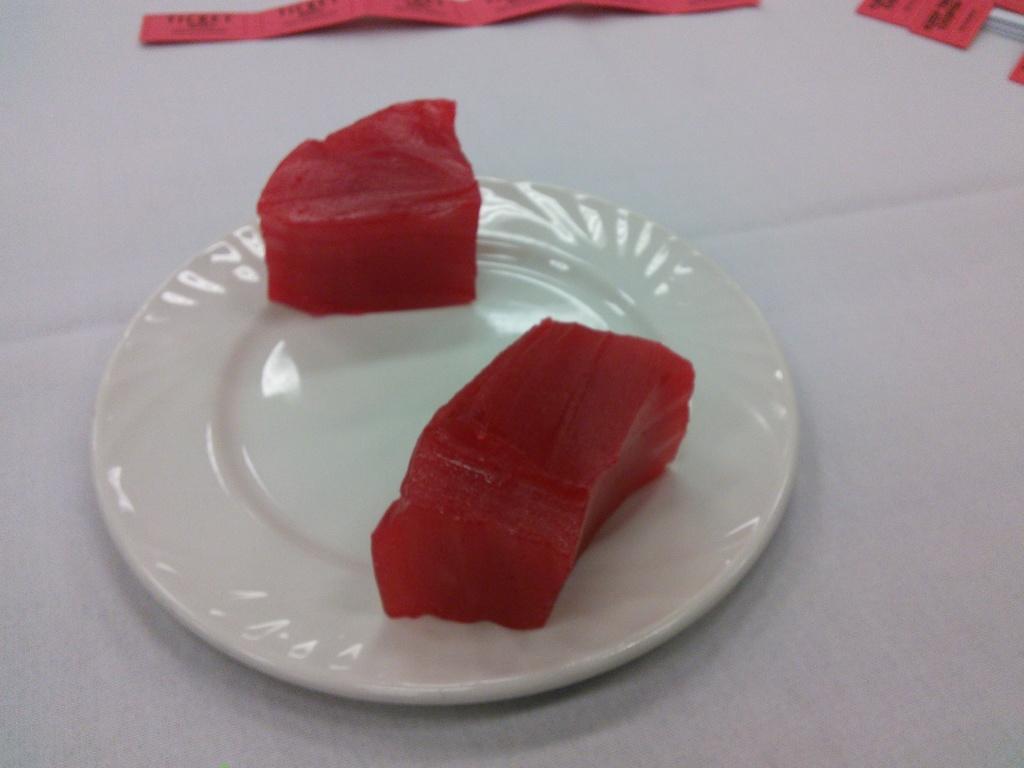Could you give a brief overview of what you see in this image? We can see plate with food and papers on white color surface. 